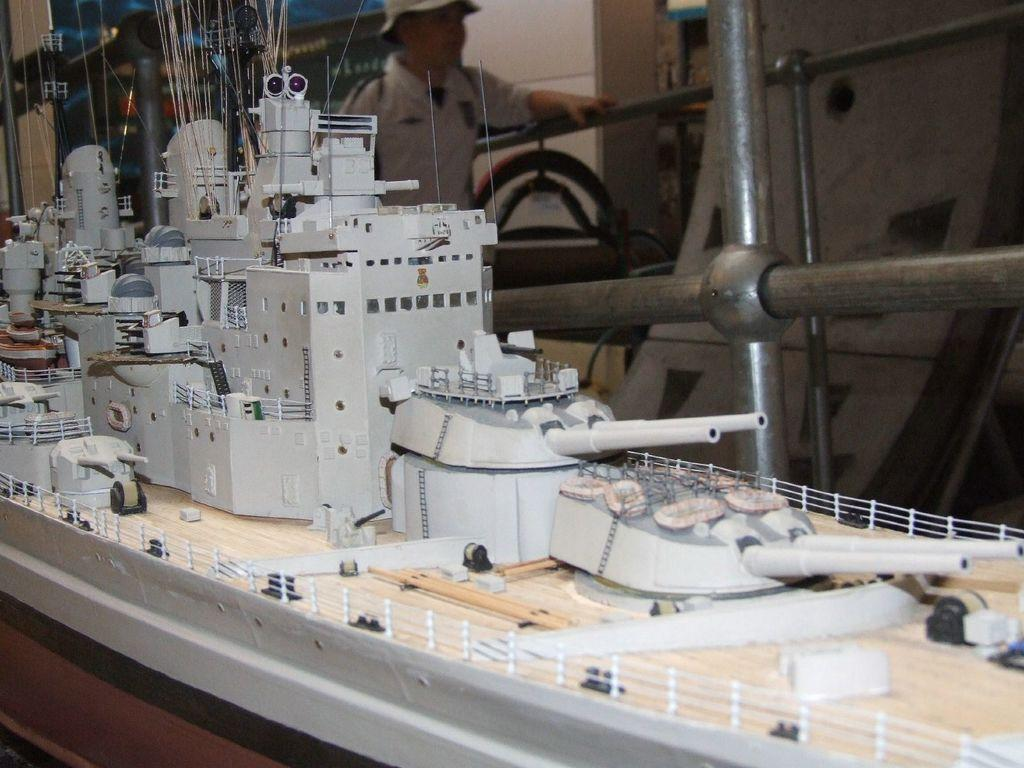What is the main object on the wooden table in the image? There is a toy ship on a wooden table in the image. Can you describe the man's position in the image? A man is standing in the background of the image. What type of objects can be seen in the background besides the man? There are pipes visible in the background, along with other unspecified objects. What type of rice is being prepared in the image? There is no rice visible or mentioned in the image. Can you describe the texture of the flesh in the image? There is no flesh visible or mentioned in the image. 